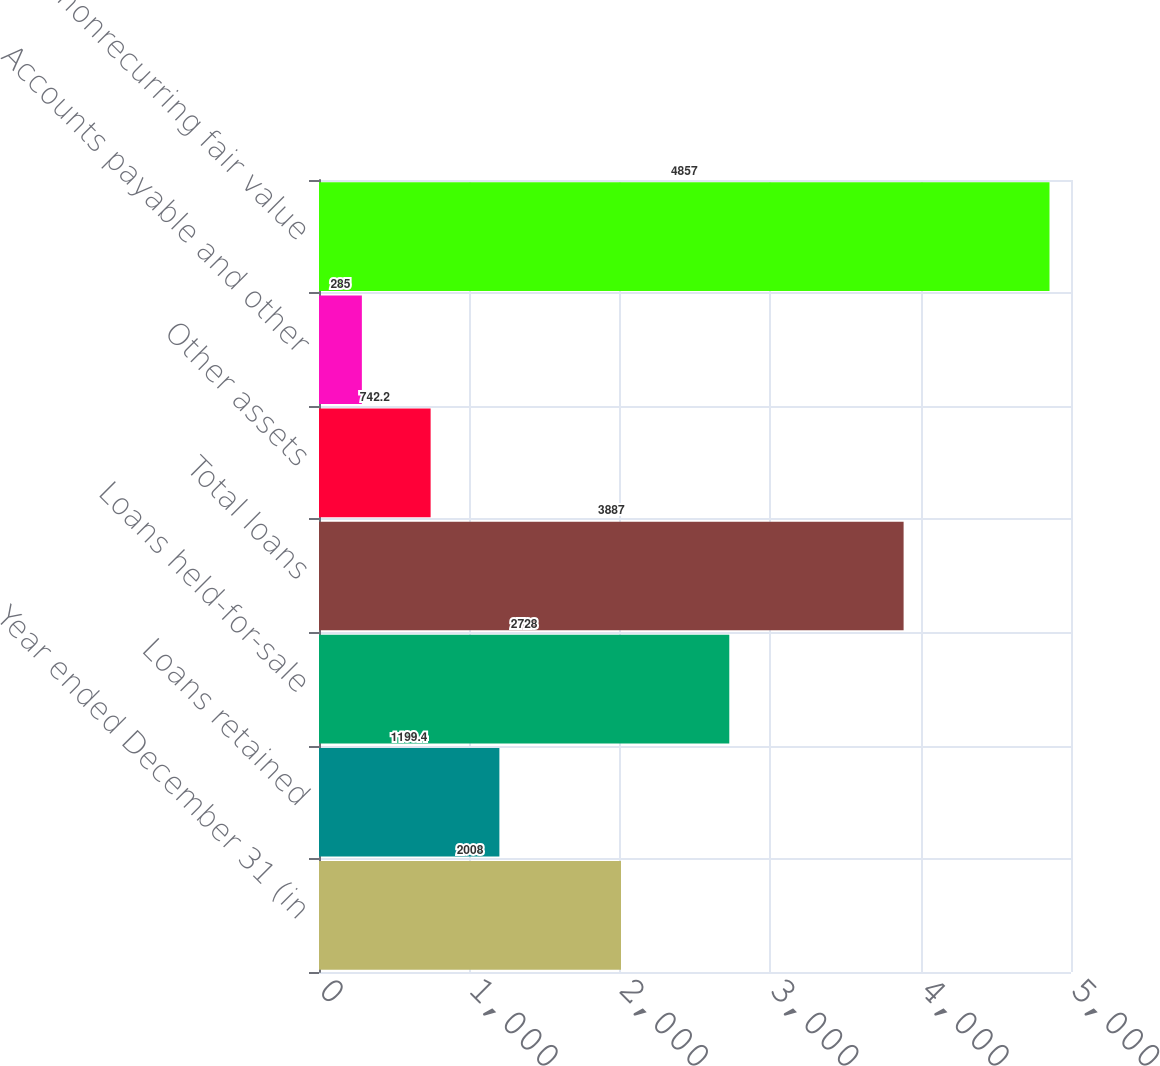Convert chart to OTSL. <chart><loc_0><loc_0><loc_500><loc_500><bar_chart><fcel>Year ended December 31 (in<fcel>Loans retained<fcel>Loans held-for-sale<fcel>Total loans<fcel>Other assets<fcel>Accounts payable and other<fcel>Total nonrecurring fair value<nl><fcel>2008<fcel>1199.4<fcel>2728<fcel>3887<fcel>742.2<fcel>285<fcel>4857<nl></chart> 